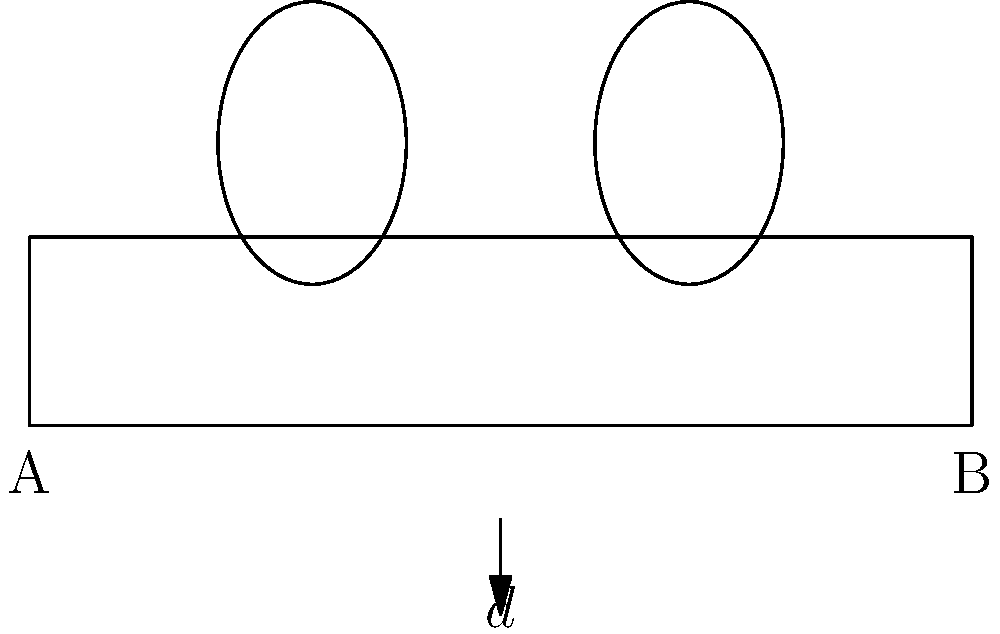In the park bench layout shown above, two people are sitting at opposite ends of the bench. If the length of the bench is $d$ meters, and each person occupies 0.5 meters of space, what is the maximum distance between them? To find the maximum distance between the two people, we need to follow these steps:

1. Understand that the total length of the bench is $d$ meters.

2. Each person occupies 0.5 meters of space on the bench.

3. The maximum distance between them would occur when they sit at the opposite ends of the bench.

4. To calculate the maximum distance, we need to subtract the space occupied by both people from the total length of the bench:

   Maximum distance = Total bench length - Space occupied by both people
   $$ \text{Maximum distance} = d - (0.5 + 0.5) $$
   $$ \text{Maximum distance} = d - 1 $$

5. Therefore, the maximum distance between the two people is $(d-1)$ meters.
Answer: $d-1$ meters 